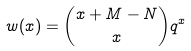<formula> <loc_0><loc_0><loc_500><loc_500>w ( x ) = \binom { x + M - N } { x } q ^ { x }</formula> 